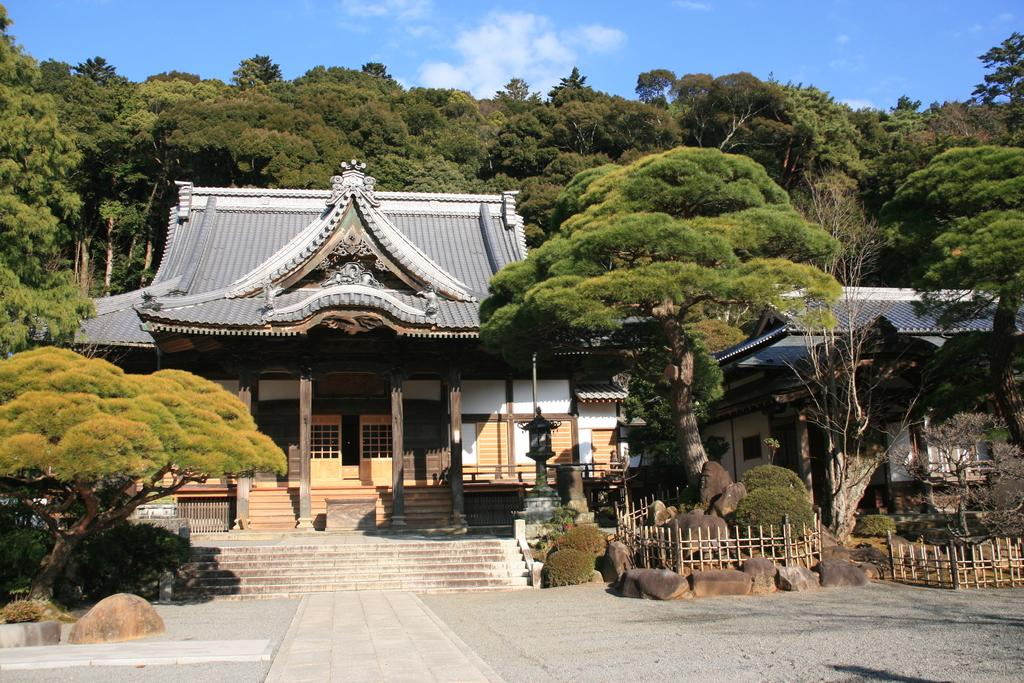What type of structures can be seen in the image? There are houses, walls, doors, and pillars in the image. What architectural features are present in the image? There are stairs and railings in the image. What natural elements can be seen in the image? There are rocks, plants, and trees in the image. What is the ground surface like in the image? There is a walkway at the bottom of the image. What is visible at the top of the image? The sky is visible at the top of the image. Can you tell me how many goose dolls are sitting on the railings in the image? There are no goose dolls present in the image. What is the relation between the houses and the trees in the image? The provided facts do not mention any relation between the houses and the trees; they are simply separate elements in the image. 